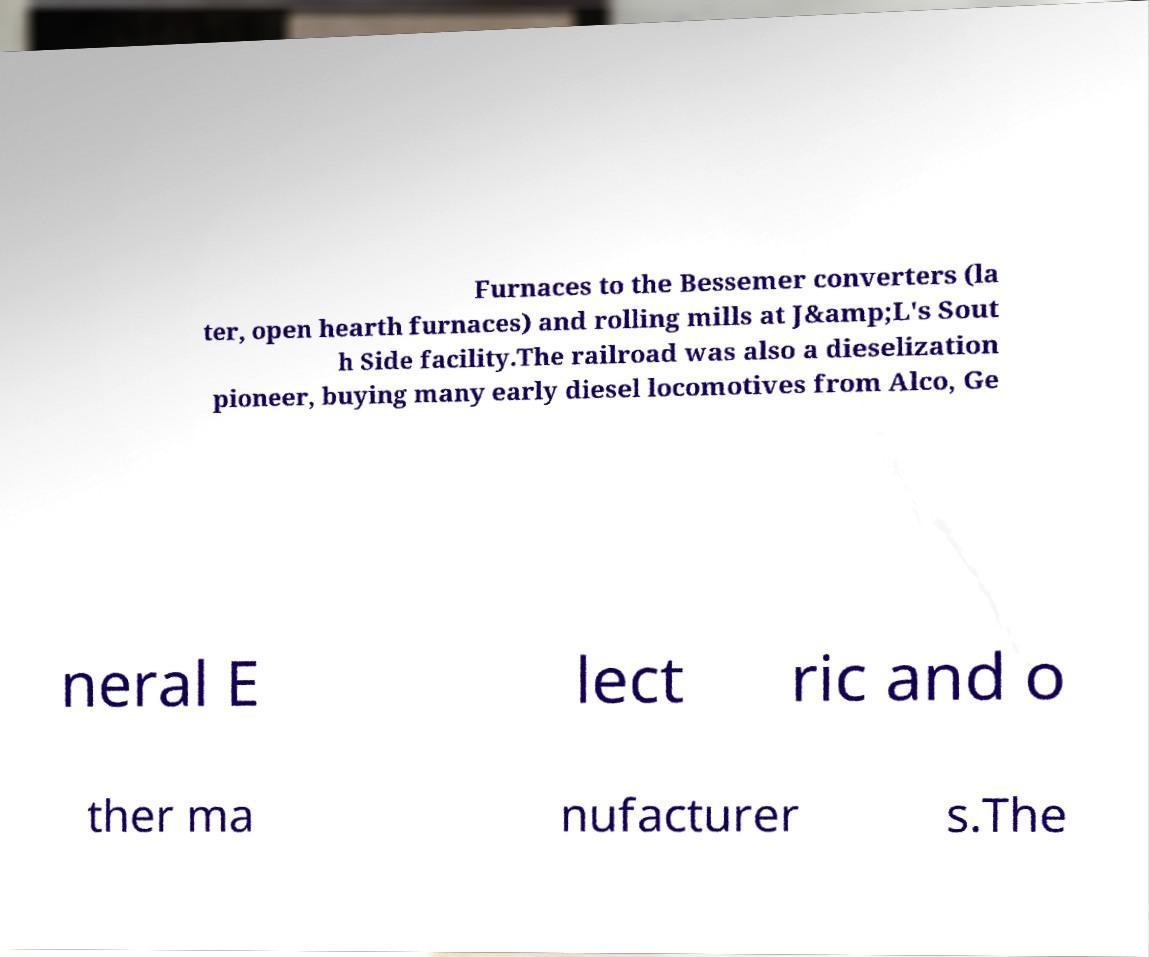Can you read and provide the text displayed in the image?This photo seems to have some interesting text. Can you extract and type it out for me? Furnaces to the Bessemer converters (la ter, open hearth furnaces) and rolling mills at J&amp;L's Sout h Side facility.The railroad was also a dieselization pioneer, buying many early diesel locomotives from Alco, Ge neral E lect ric and o ther ma nufacturer s.The 